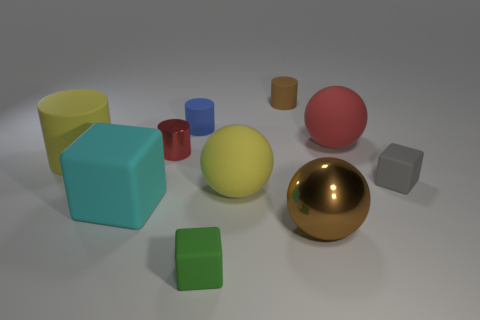Can you describe the objects situated to the left of the gold ball? On the left of the shiny gold ball, there are two geometric objects: a large blue cube and a small green cube. The large blue cube is the most prominent object in that group, with the smaller green cube positioned in front of it. 